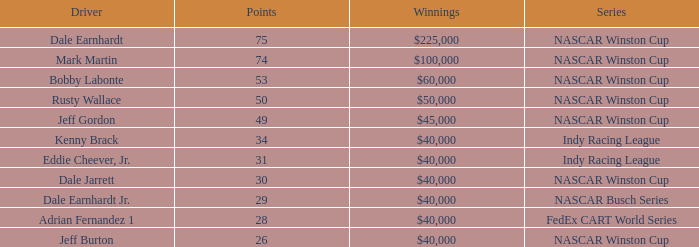What position did the driver earn 31 points? 7.0. 